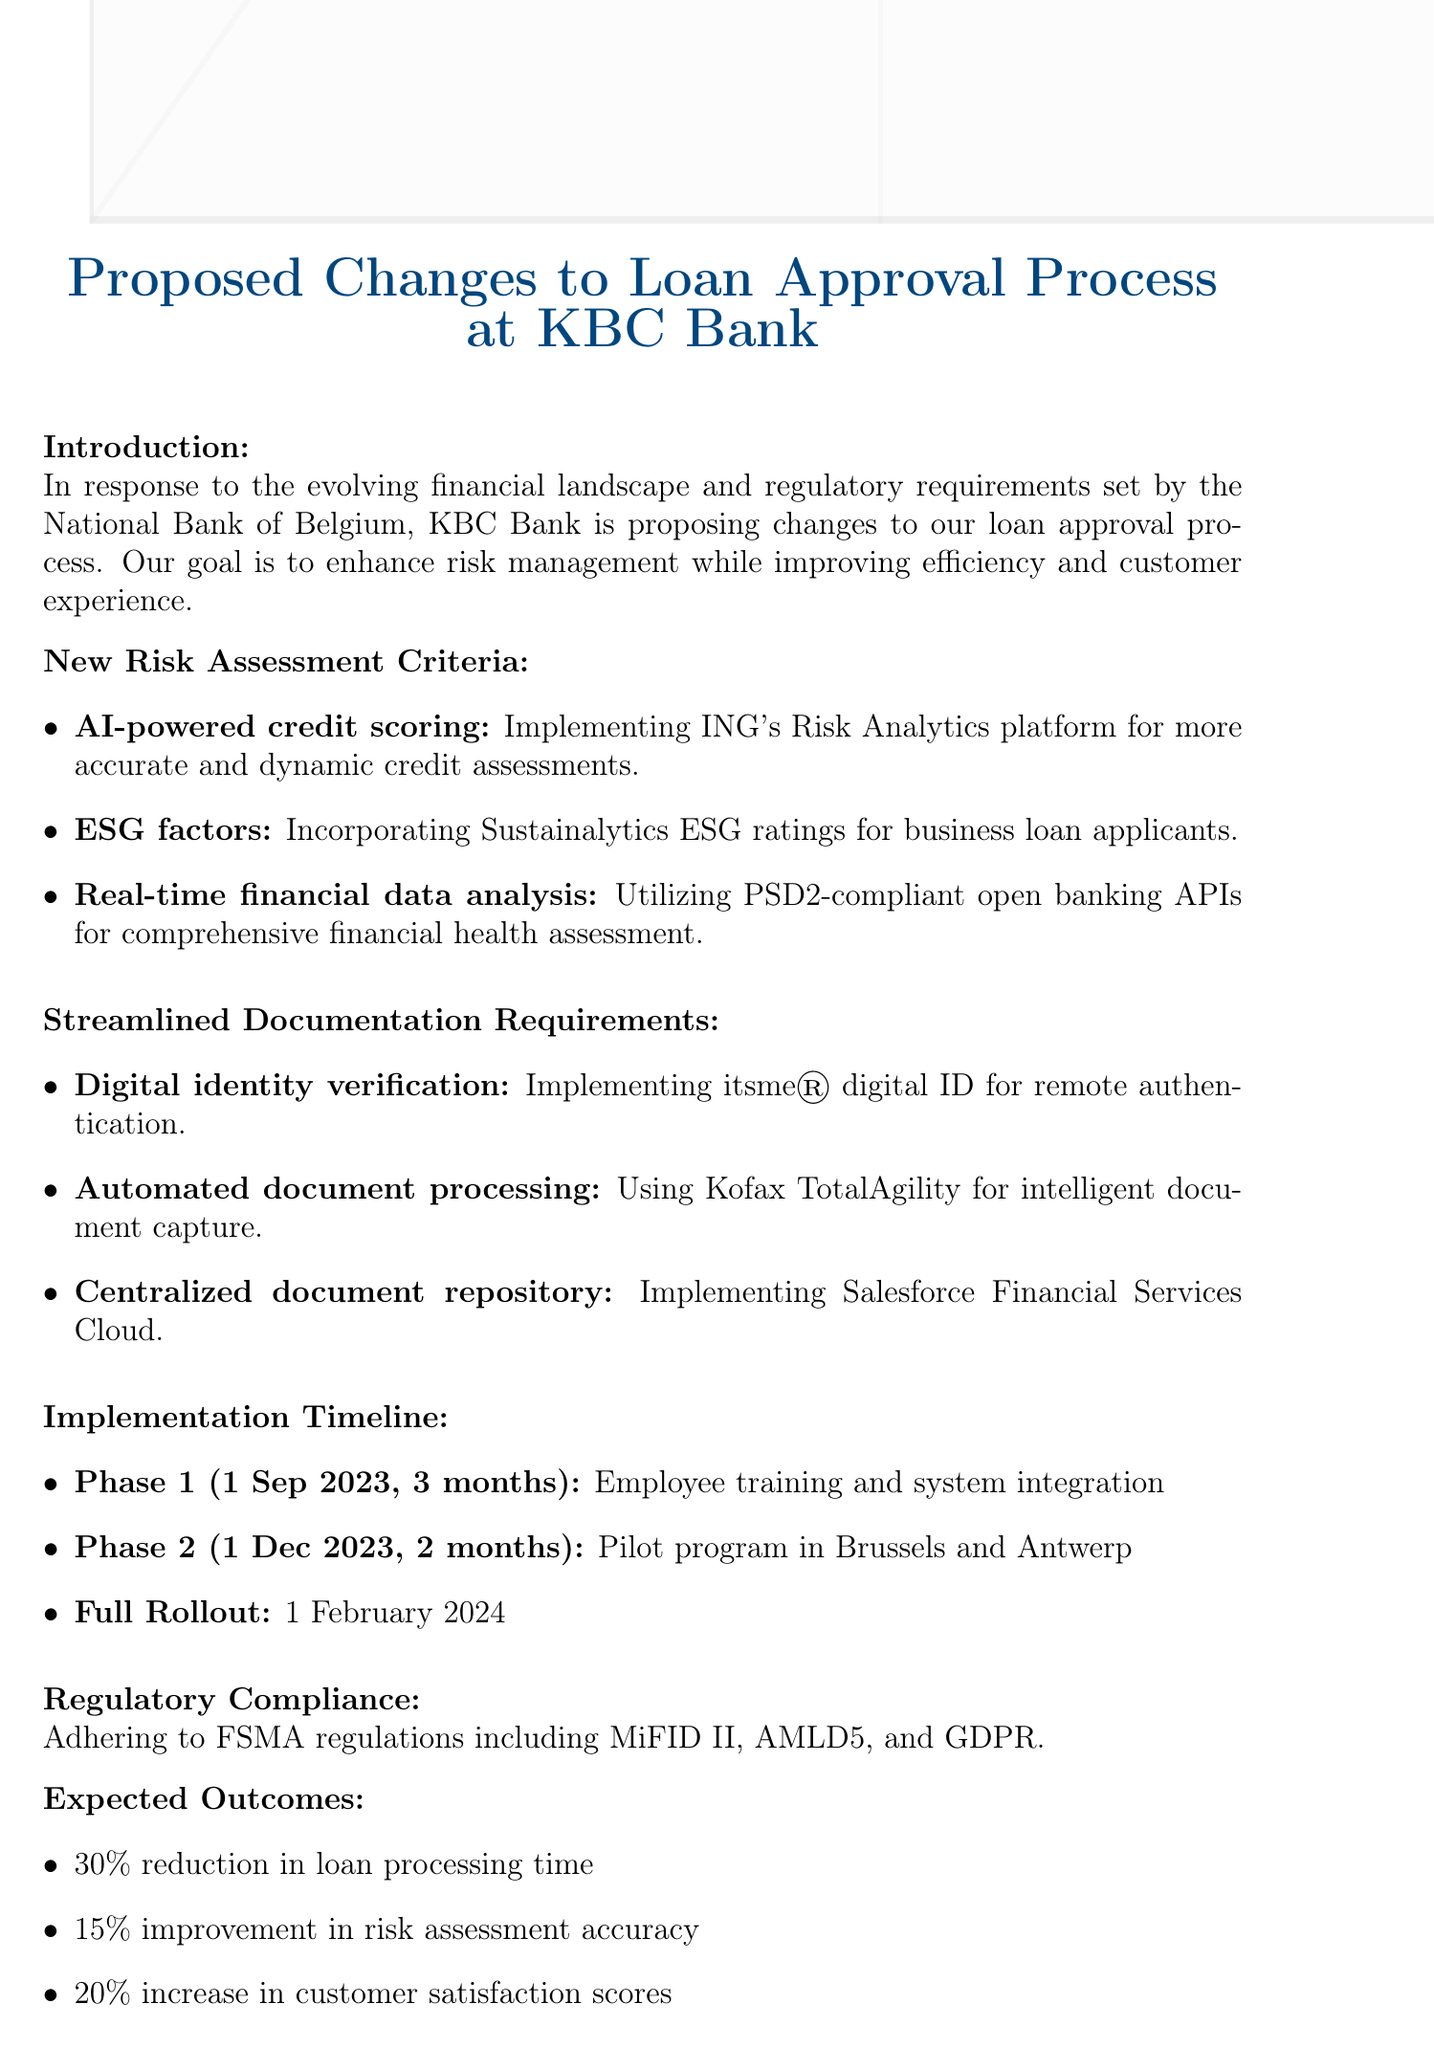what is the title of the memo? The title is specified at the beginning of the document.
Answer: Proposed Changes to Loan Approval Process at KBC Bank what is the implementation timeline start date of phase 1? The start date of phase 1 is mentioned in the implementation timeline section.
Answer: 1 September 2023 how long will phase 2 of the implementation last? The duration of phase 2 is indicated in the implementation timeline section.
Answer: 2 months which regulation aligns with integrating ESG ratings for business loan applicants? The document mentions the regulation that relates to ESG factors.
Answer: EU Sustainable Finance Disclosure Regulation (SFDR) what is the expected reduction in loan processing time? The expected outcomes section lists the anticipated improvement metrics.
Answer: 30% what tool will be used for automated document processing? The document specifies the technology intended for automated processing.
Answer: Kofax TotalAgility who needs to approve the proposed changes before implementation? The document identifies the approving body necessary for proceeding with changes.
Answer: Board of Directors what is the focus of phase 1 implementation? The document outlines the main activities planned for phase 1.
Answer: Employee training and system integration what are the ESG ratings incorporated into the new risk assessment? The document specifies the source of ESG ratings for business loans.
Answer: Sustainalytics 